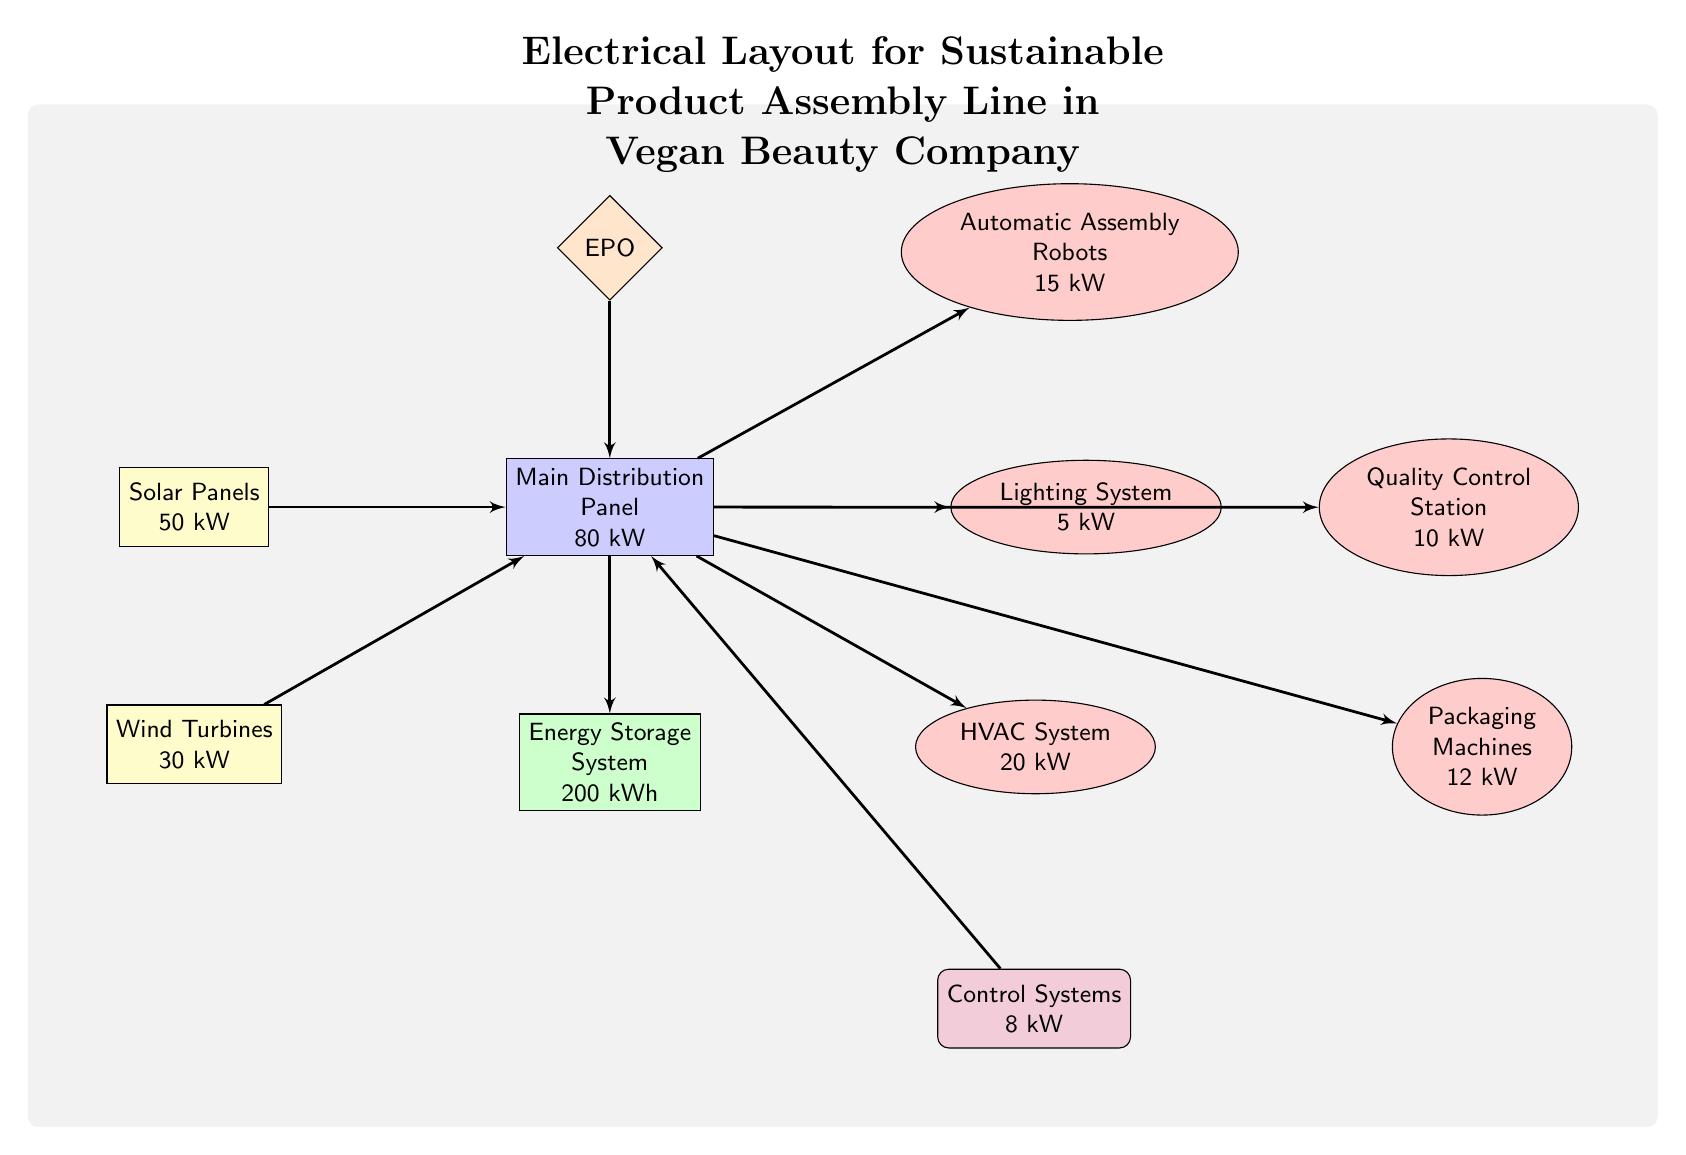What is the total power generation capacity of the energy sources? The total power generation is the sum of the capacities of the solar panels and wind turbines, which are 50 kW and 30 kW respectively. Adding these values gives 50 kW + 30 kW = 80 kW.
Answer: 80 kW How many loads are connected to the main distribution panel? The loads connected to the main distribution panel include the automatic assembly robots, lighting system, HVAC system, quality control station, and packaging machines. Counting these gives a total of 5 loads.
Answer: 5 What is the power requirement of the HVAC system? The HVAC system is labeled with a power requirement of 20 kW as indicated in the diagram.
Answer: 20 kW Which safety feature is connected to the main distribution panel? The emergency power off (EPO) safety feature is shown connecting to the main distribution panel in the diagram.
Answer: EPO What is the maximum capacity of the energy storage system? The energy storage system is labeled with a capacity of 200 kWh in the diagram, which indicates how much energy it can store.
Answer: 200 kWh Explain how energy from both solar panels and wind turbines reaches the energy storage system. Energy flows from the solar panels and wind turbines into the main distribution panel. From there, the energy is directed to the energy storage system, which means it combines the energy from both sources before being stored.
Answer: Through the main distribution panel What is the total power consumption of all loads connected to the main distribution panel? The total power consumption is calculated by adding the power requirements of all loads connected to the main distribution panel: robots (15 kW), lighting (5 kW), HVAC (20 kW), quality control (10 kW), and packaging (12 kW). Summing these gives 15 + 5 + 20 + 10 + 12 = 72 kW.
Answer: 72 kW What is the function of the control systems in the layout? The control systems are labeled with a power requirement of 8 kW and are connected to the main distribution panel. Their function typically involves managing other connected systems and ensuring efficient operation, although the exact function is not specified in the diagram.
Answer: Control Systems 